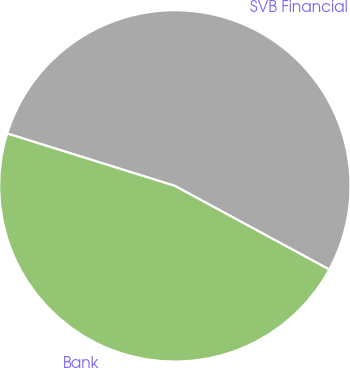<chart> <loc_0><loc_0><loc_500><loc_500><pie_chart><fcel>SVB Financial<fcel>Bank<nl><fcel>53.08%<fcel>46.92%<nl></chart> 